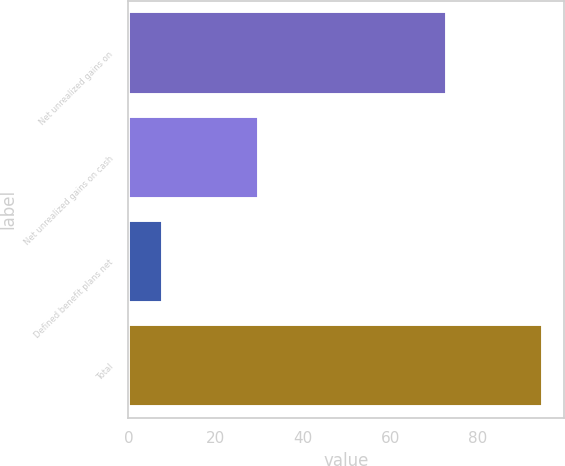Convert chart to OTSL. <chart><loc_0><loc_0><loc_500><loc_500><bar_chart><fcel>Net unrealized gains on<fcel>Net unrealized gains on cash<fcel>Defined benefit plans net<fcel>Total<nl><fcel>73<fcel>30<fcel>8<fcel>95<nl></chart> 